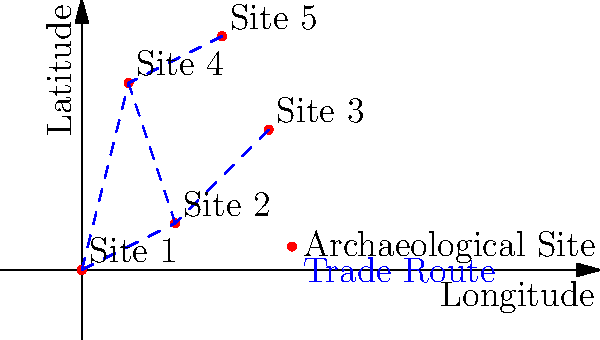Based on the distribution of artifacts across the five archaeological sites shown in the map, which site appears to be the most crucial hub in the ancient trade network, and why? Consider the concept of centrality in your analysis. To determine the most crucial hub in the ancient trade network, we need to analyze the centrality of each site based on the given map. Here's a step-by-step approach:

1. Identify the connections:
   - Site 1 connects to Sites 2 and 4
   - Site 2 connects to Sites 1, 3, and 4
   - Site 3 connects to Site 2
   - Site 4 connects to Sites 1, 2, and 5
   - Site 5 connects to Site 4

2. Calculate the degree centrality (number of direct connections):
   - Site 1: 2 connections
   - Site 2: 3 connections
   - Site 3: 1 connection
   - Site 4: 3 connections
   - Site 5: 1 connection

3. Analyze betweenness centrality (how often a site acts as a bridge):
   - Site 2 and Site 4 both appear on paths between other sites more frequently than the others.

4. Consider the geographical position:
   - Site 2 is centrally located, connecting the western (Sites 1 and 4) and eastern (Site 3) parts of the network.
   - Site 4 connects the southern (Sites 1 and 2) and northern (Site 5) parts of the network.

5. Evaluate the overall importance:
   - Site 2 has high degree centrality, high betweenness centrality, and a strategic central location.
   - It connects the most distant sites (1 and 3) and links to the other central node (Site 4).

Based on this analysis, Site 2 appears to be the most crucial hub in the ancient trade network. It has the highest degree centrality (tied with Site 4), high betweenness centrality, and a strategic central location that connects different regions of the network.
Answer: Site 2, due to high degree and betweenness centrality and strategic location. 